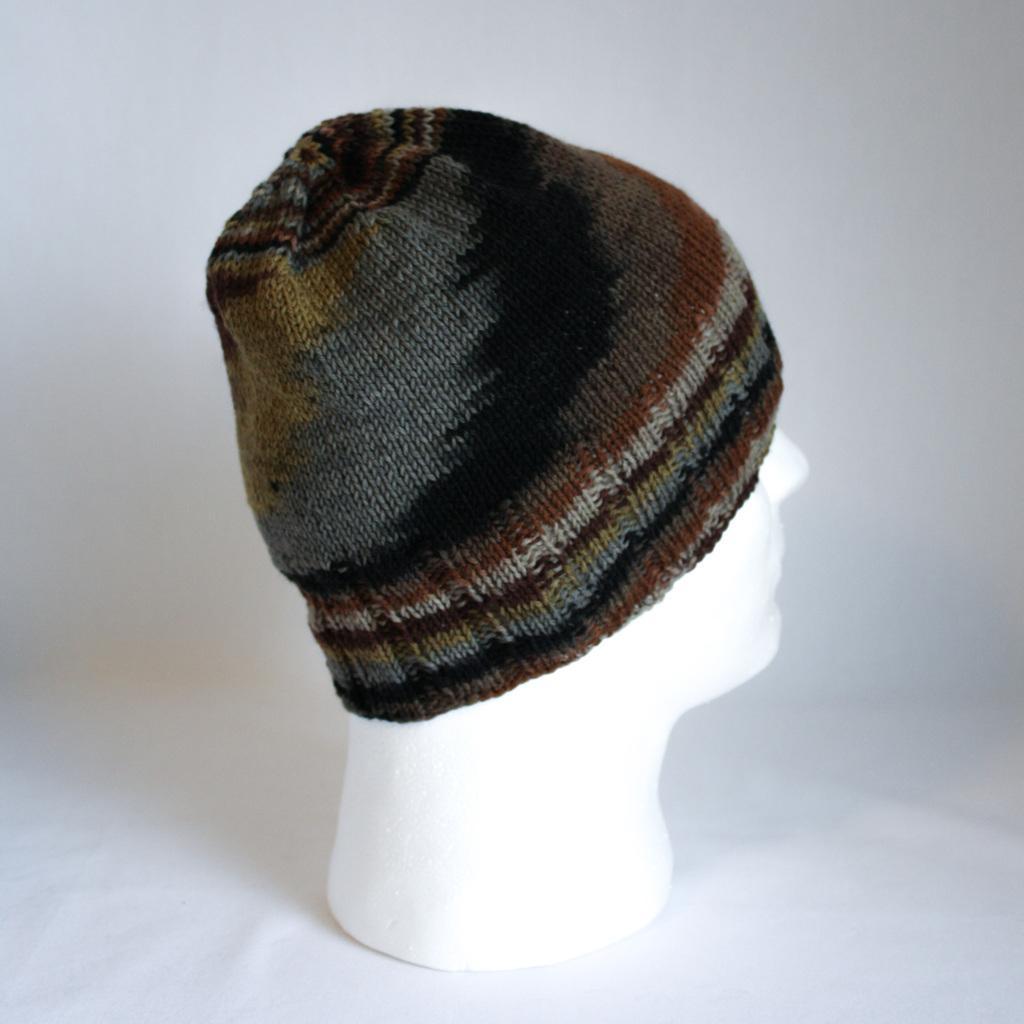How would you summarize this image in a sentence or two? In this image, in the middle, we can see a mannequin wearing a cap. In the background, we can see white color. 